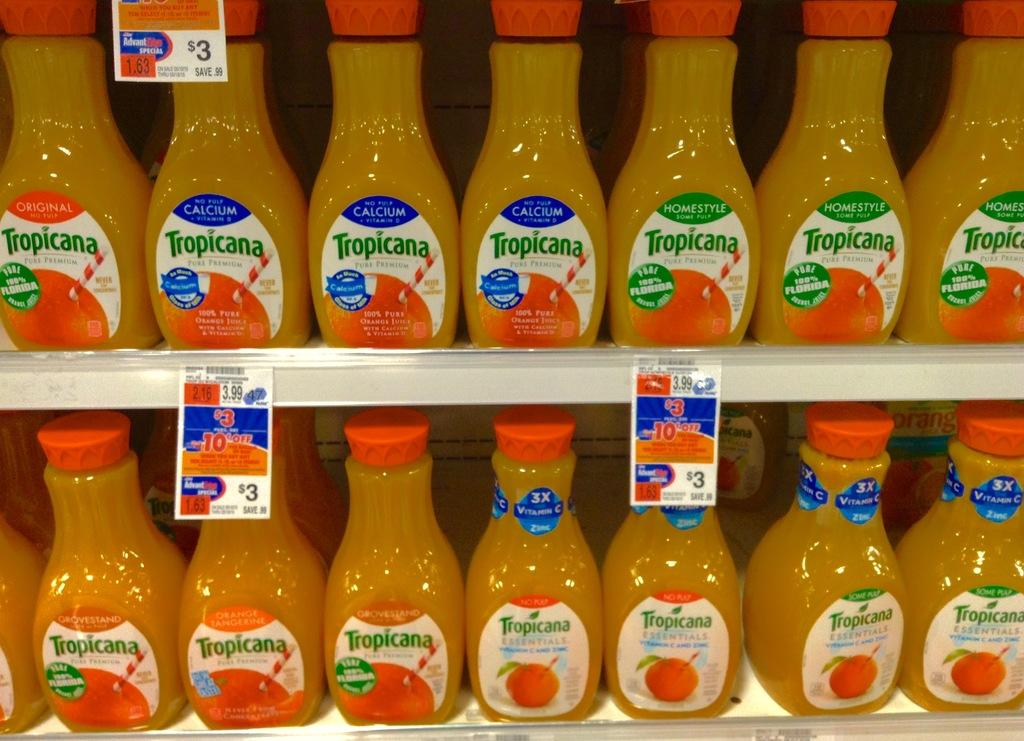<image>
Render a clear and concise summary of the photo. lots  of new bottle of orange juice tropicana 